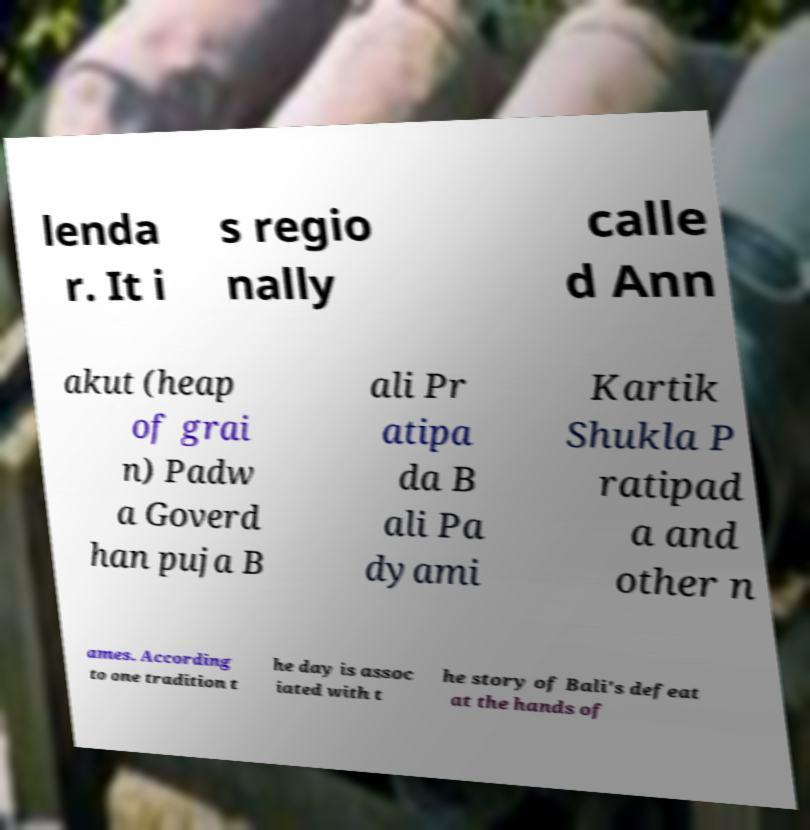Could you assist in decoding the text presented in this image and type it out clearly? lenda r. It i s regio nally calle d Ann akut (heap of grai n) Padw a Goverd han puja B ali Pr atipa da B ali Pa dyami Kartik Shukla P ratipad a and other n ames. According to one tradition t he day is assoc iated with t he story of Bali's defeat at the hands of 